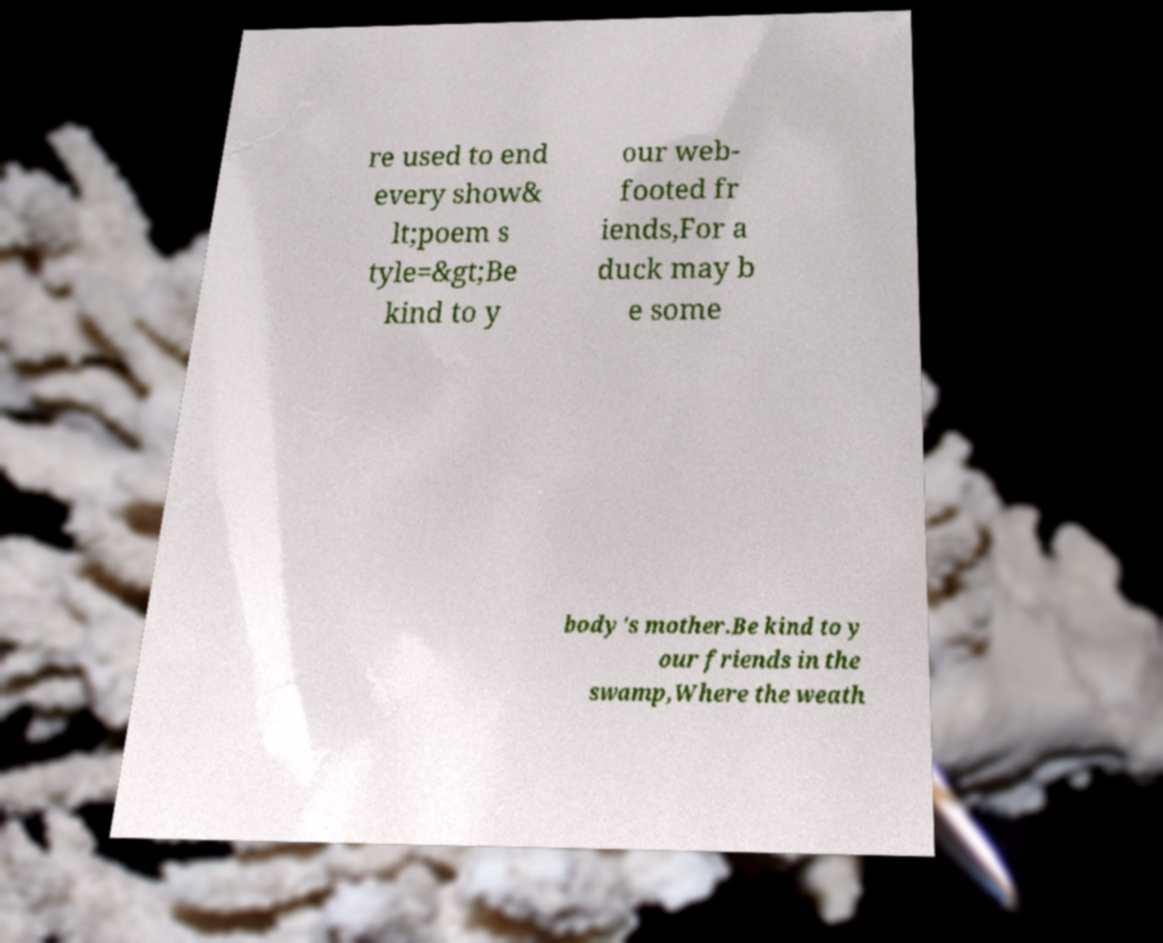Could you extract and type out the text from this image? re used to end every show& lt;poem s tyle=&gt;Be kind to y our web- footed fr iends,For a duck may b e some body's mother.Be kind to y our friends in the swamp,Where the weath 